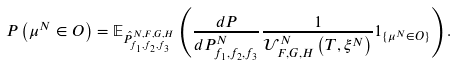<formula> <loc_0><loc_0><loc_500><loc_500>P \left ( \mu ^ { N } \in O \right ) = \mathbb { E } _ { \hat { P } ^ { N , F , G , H } _ { f _ { 1 } , f _ { 2 } , f _ { 3 } } } \left ( \frac { d P } { d P ^ { N } _ { f _ { 1 } , f _ { 2 } , f _ { 3 } } } \frac { 1 } { \mathcal { U } ^ { N } _ { F , G , H } \left ( T , \xi ^ { N } \right ) } 1 _ { \{ \mu ^ { N } \in O \} } \right ) .</formula> 